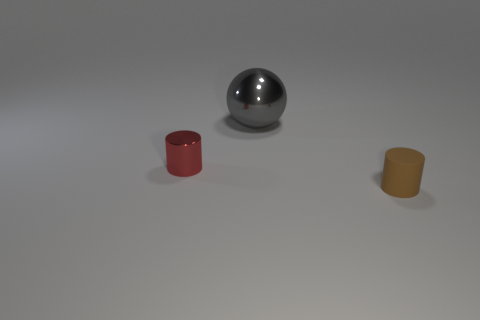Is there any other thing that has the same material as the small brown cylinder?
Your response must be concise. No. What material is the other tiny thing that is the same shape as the tiny red object?
Keep it short and to the point. Rubber. What material is the small cylinder that is behind the thing in front of the tiny cylinder that is behind the tiny rubber cylinder?
Offer a terse response. Metal. What is the size of the ball that is made of the same material as the tiny red cylinder?
Provide a succinct answer. Large. What is the color of the cylinder that is on the right side of the red object?
Your answer should be compact. Brown. There is a cylinder that is to the left of the matte cylinder; is it the same size as the big shiny sphere?
Keep it short and to the point. No. Are there fewer tiny metal objects than small yellow blocks?
Your answer should be very brief. No. There is a tiny red object; how many red objects are on the right side of it?
Your response must be concise. 0. Does the tiny red object have the same shape as the small brown object?
Provide a succinct answer. Yes. How many things are both to the right of the small red metal object and in front of the large gray metallic ball?
Keep it short and to the point. 1. 